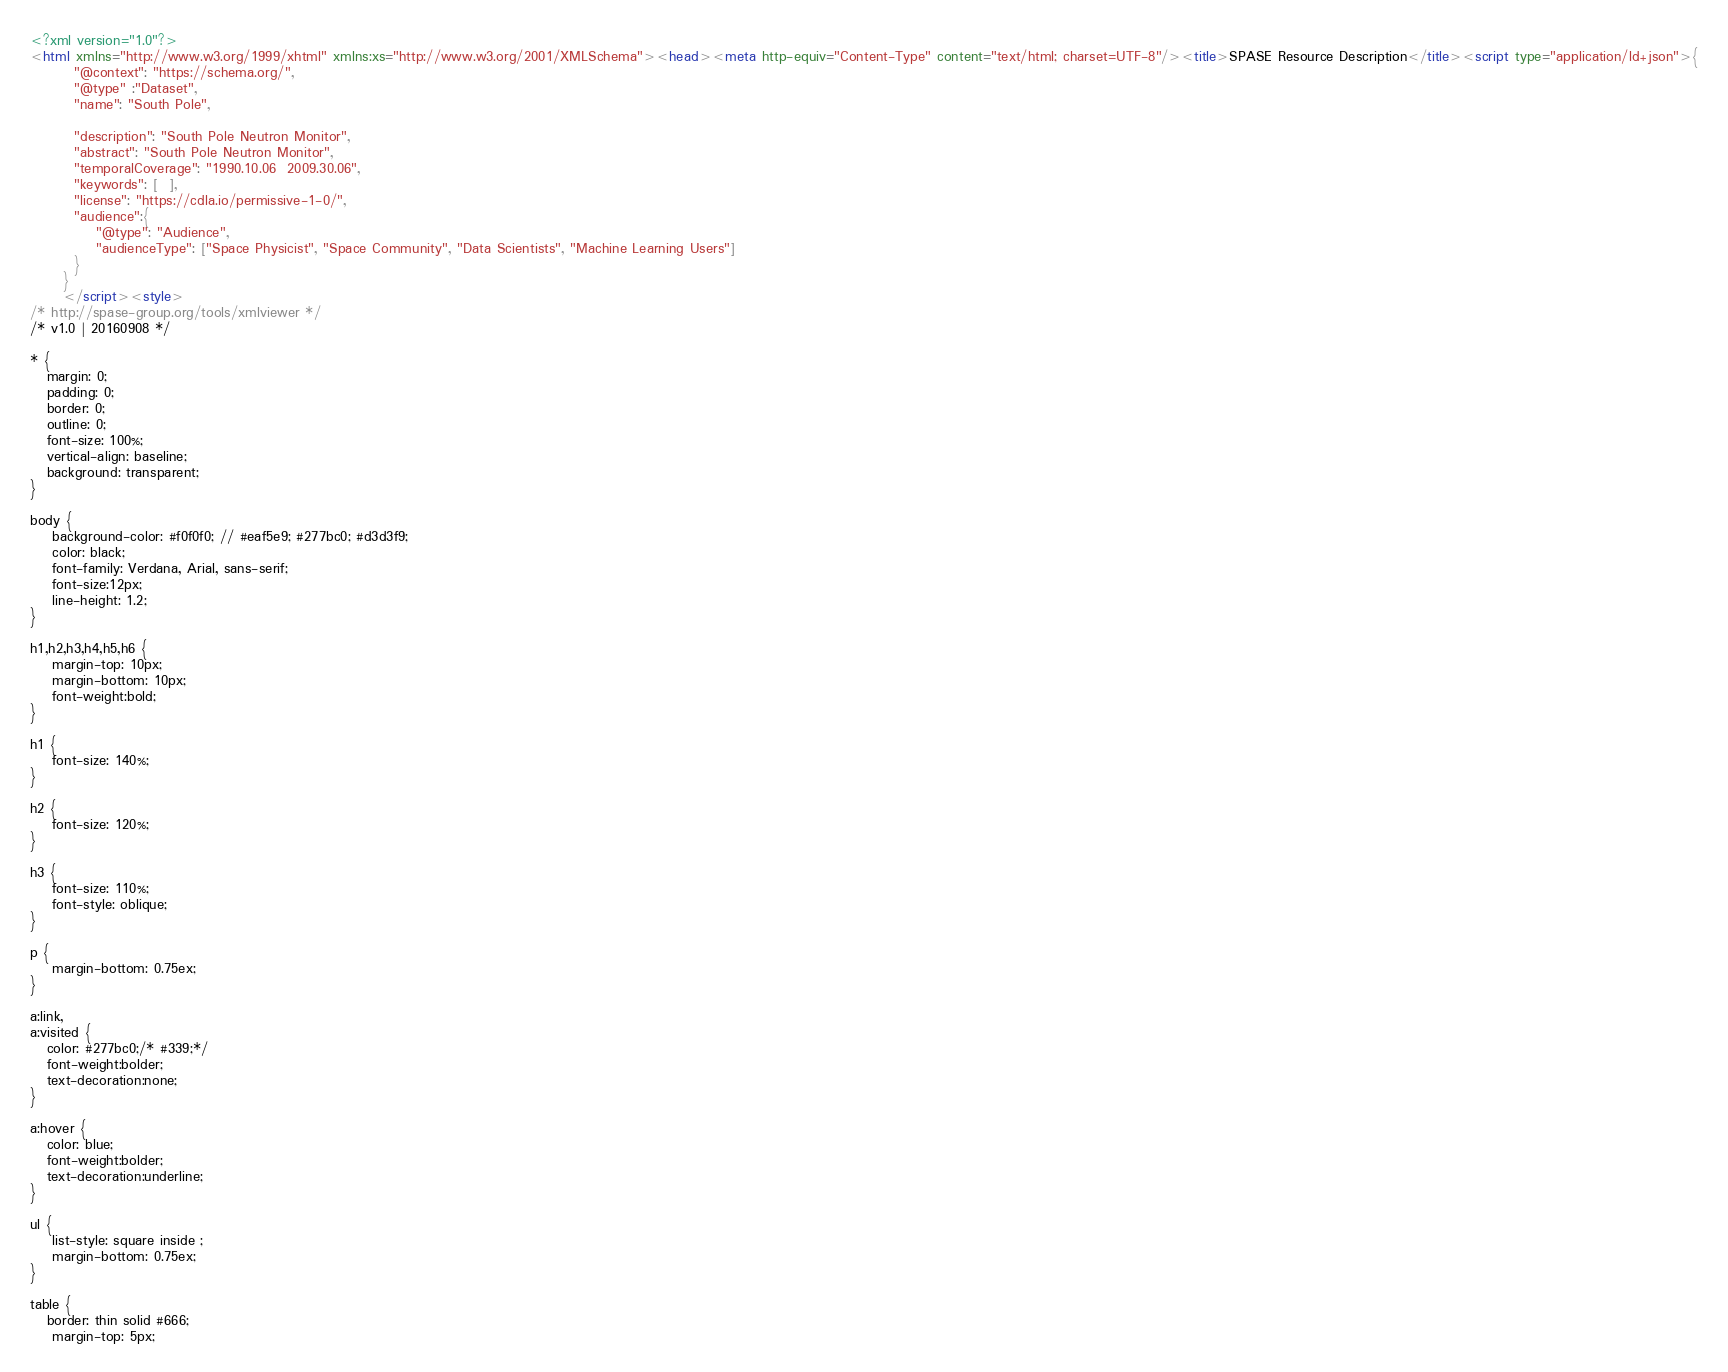Convert code to text. <code><loc_0><loc_0><loc_500><loc_500><_HTML_><?xml version="1.0"?>
<html xmlns="http://www.w3.org/1999/xhtml" xmlns:xs="http://www.w3.org/2001/XMLSchema"><head><meta http-equiv="Content-Type" content="text/html; charset=UTF-8"/><title>SPASE Resource Description</title><script type="application/ld+json">{
		"@context": "https://schema.org/",
		"@type" :"Dataset",
		"name": "South Pole",
     
 		"description": "South Pole Neutron Monitor",
		"abstract": "South Pole Neutron Monitor",
		"temporalCoverage": "1990.10.06  2009.30.06",
		"keywords": [  ],
		"license": "https://cdla.io/permissive-1-0/",
        "audience":{
            "@type": "Audience",
            "audienceType": ["Space Physicist", "Space Community", "Data Scientists", "Machine Learning Users"]
        }
	  }
	  </script><style>
/* http://spase-group.org/tools/xmlviewer */
/* v1.0 | 20160908 */

* {
   margin: 0;
   padding: 0;
   border: 0;
   outline: 0;
   font-size: 100%;
   vertical-align: baseline;
   background: transparent;
}

body {
	background-color: #f0f0f0; // #eaf5e9; #277bc0; #d3d3f9;
	color: black;
	font-family: Verdana, Arial, sans-serif; 
	font-size:12px; 
	line-height: 1.2;
}
 
h1,h2,h3,h4,h5,h6 {
	margin-top: 10px;
	margin-bottom: 10px;
	font-weight:bold;
}

h1 {
	font-size: 140%;
}

h2 {
	font-size: 120%;
}

h3 {
	font-size: 110%;
	font-style: oblique;
}

p {
	margin-bottom: 0.75ex;
}

a:link,
a:visited {
   color: #277bc0;/* #339;*/
   font-weight:bolder; 
   text-decoration:none; 
}

a:hover {
   color: blue;
   font-weight:bolder; 
   text-decoration:underline; 
}

ul {
	list-style: square inside ;
	margin-bottom: 0.75ex;
}

table {
   border: thin solid #666;
	margin-top: 5px;</code> 